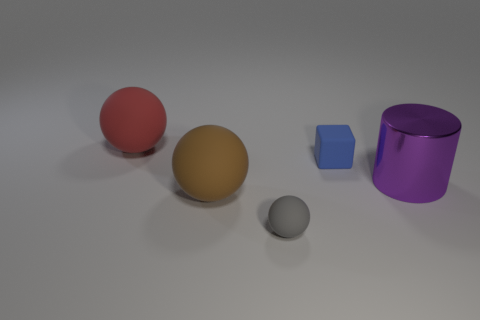Add 4 large purple cylinders. How many objects exist? 9 Subtract all large rubber balls. How many balls are left? 1 Subtract all brown spheres. How many spheres are left? 2 Subtract all cylinders. How many objects are left? 4 Subtract 3 spheres. How many spheres are left? 0 Subtract all gray blocks. How many yellow cylinders are left? 0 Subtract all blocks. Subtract all big red matte spheres. How many objects are left? 3 Add 4 cylinders. How many cylinders are left? 5 Add 4 purple metal things. How many purple metal things exist? 5 Subtract 1 brown spheres. How many objects are left? 4 